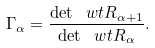Convert formula to latex. <formula><loc_0><loc_0><loc_500><loc_500>\Gamma _ { \alpha } = \frac { \det \ w t R _ { \alpha + 1 } } { \det \ w t R _ { \alpha } } .</formula> 